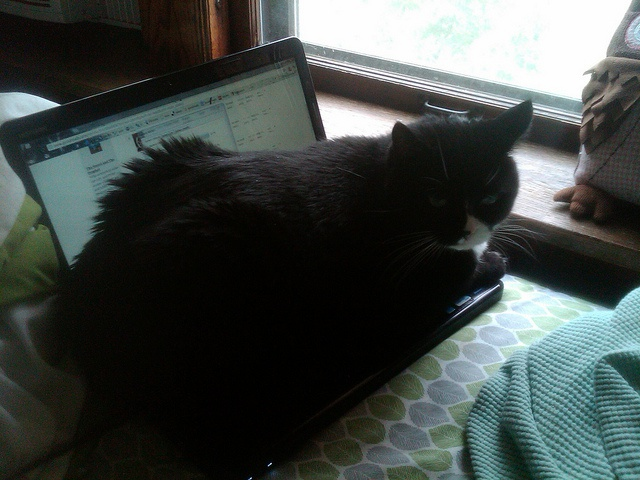Describe the objects in this image and their specific colors. I can see cat in black, gray, and purple tones and laptop in black, gray, and teal tones in this image. 